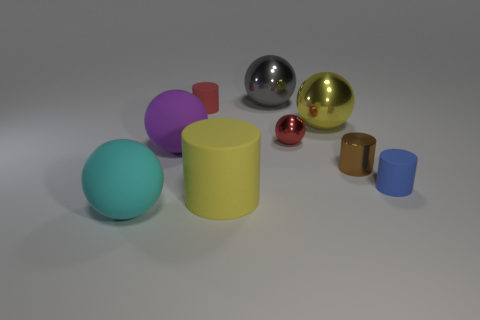There is a big matte ball that is in front of the blue thing; is its color the same as the tiny metal sphere?
Ensure brevity in your answer.  No. Is the number of gray shiny objects right of the gray ball the same as the number of yellow spheres?
Your answer should be compact. No. Are there any large spheres of the same color as the big matte cylinder?
Offer a terse response. Yes. Does the blue cylinder have the same size as the red rubber thing?
Your answer should be compact. Yes. What size is the cylinder that is behind the yellow object to the right of the yellow matte thing?
Ensure brevity in your answer.  Small. There is a matte thing that is both behind the tiny brown metal object and to the right of the big purple matte sphere; what size is it?
Ensure brevity in your answer.  Small. How many blue blocks are the same size as the cyan ball?
Keep it short and to the point. 0. How many matte objects are either small spheres or large yellow cubes?
Your answer should be very brief. 0. The thing that is the same color as the large matte cylinder is what size?
Your answer should be very brief. Large. The yellow thing in front of the large yellow object that is behind the metallic cylinder is made of what material?
Offer a terse response. Rubber. 